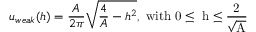<formula> <loc_0><loc_0><loc_500><loc_500>u _ { w e a k } ( h ) = \frac { A } { 2 \pi } \sqrt { \frac { 4 } { A } - h ^ { 2 } } , w i t h 0 \leq h \leq \frac { 2 } { \sqrt { A } }</formula> 